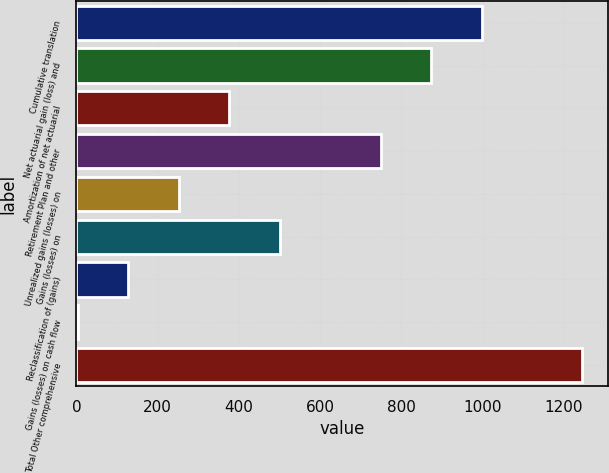<chart> <loc_0><loc_0><loc_500><loc_500><bar_chart><fcel>Cumulative translation<fcel>Net actuarial gain (loss) and<fcel>Amortization of net actuarial<fcel>Retirement Plan and other<fcel>Unrealized gains (losses) on<fcel>Gains (losses) on<fcel>Reclassification of (gains)<fcel>Gains (losses) on cash flow<fcel>Total Other comprehensive<nl><fcel>997.6<fcel>873.4<fcel>376.6<fcel>749.2<fcel>252.4<fcel>500.8<fcel>128.2<fcel>4<fcel>1246<nl></chart> 